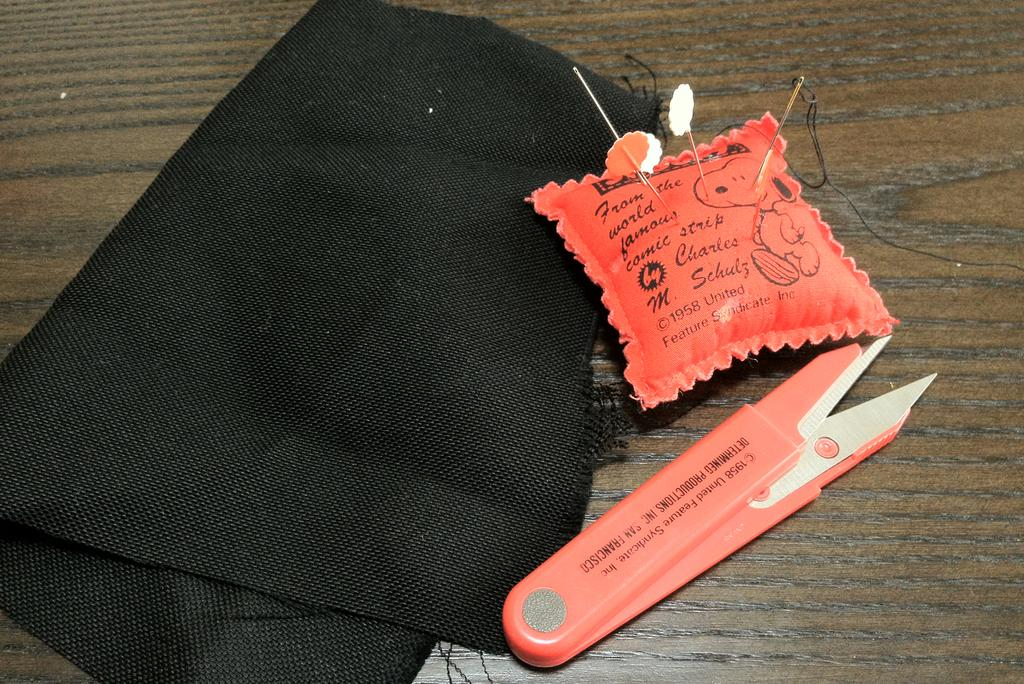<image>
Provide a brief description of the given image. An orange pin cushion that says From the world famous comic strip on it. 